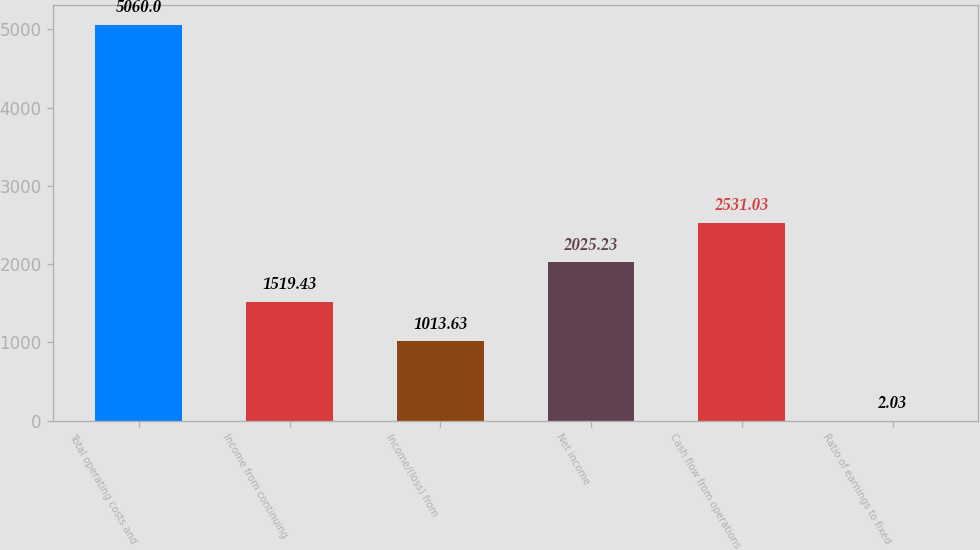<chart> <loc_0><loc_0><loc_500><loc_500><bar_chart><fcel>Total operating costs and<fcel>Income from continuing<fcel>Income/(loss) from<fcel>Net income<fcel>Cash flow from operations<fcel>Ratio of earnings to fixed<nl><fcel>5060<fcel>1519.43<fcel>1013.63<fcel>2025.23<fcel>2531.03<fcel>2.03<nl></chart> 